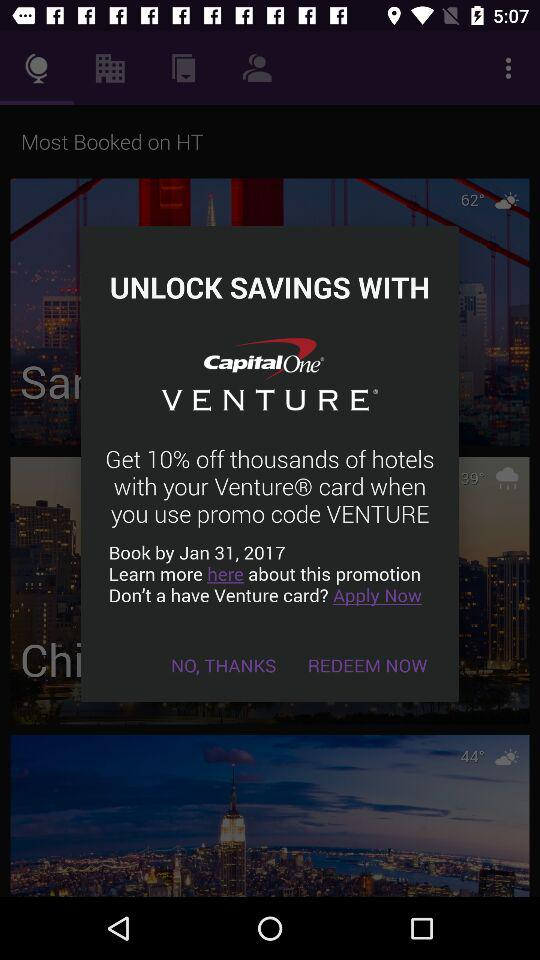What is the promo code given on the screen? The promo code is "VENTURE". 